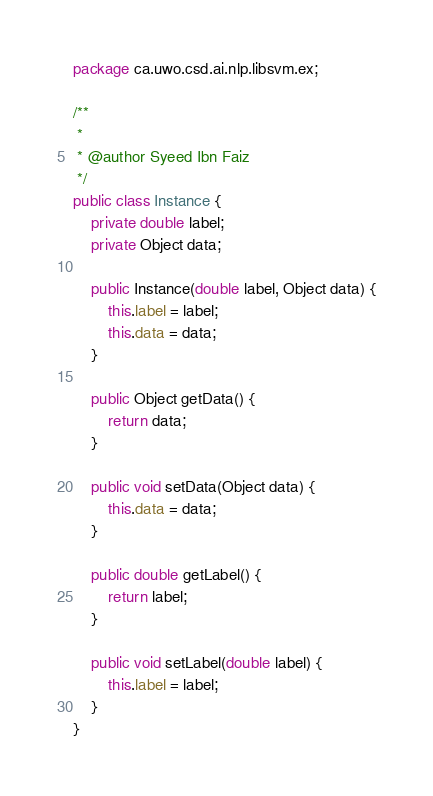<code> <loc_0><loc_0><loc_500><loc_500><_Java_>package ca.uwo.csd.ai.nlp.libsvm.ex;

/**
 *
 * @author Syeed Ibn Faiz
 */
public class Instance {
    private double label;
    private Object data;

    public Instance(double label, Object data) {
        this.label = label;
        this.data = data;
    }

    public Object getData() {
        return data;
    }

    public void setData(Object data) {
        this.data = data;
    }

    public double getLabel() {
        return label;
    }

    public void setLabel(double label) {
        this.label = label;
    }            
}
</code> 